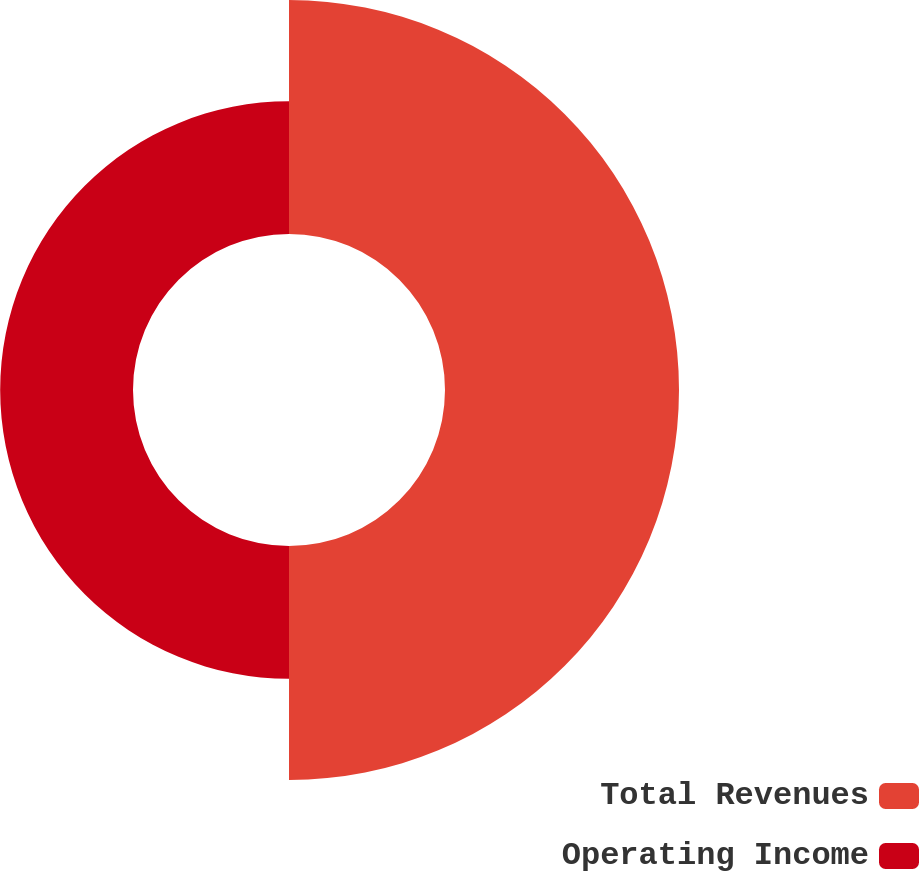Convert chart. <chart><loc_0><loc_0><loc_500><loc_500><pie_chart><fcel>Total Revenues<fcel>Operating Income<nl><fcel>63.79%<fcel>36.21%<nl></chart> 